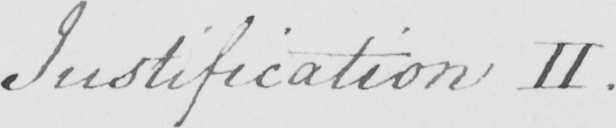What text is written in this handwritten line? Justification II . 